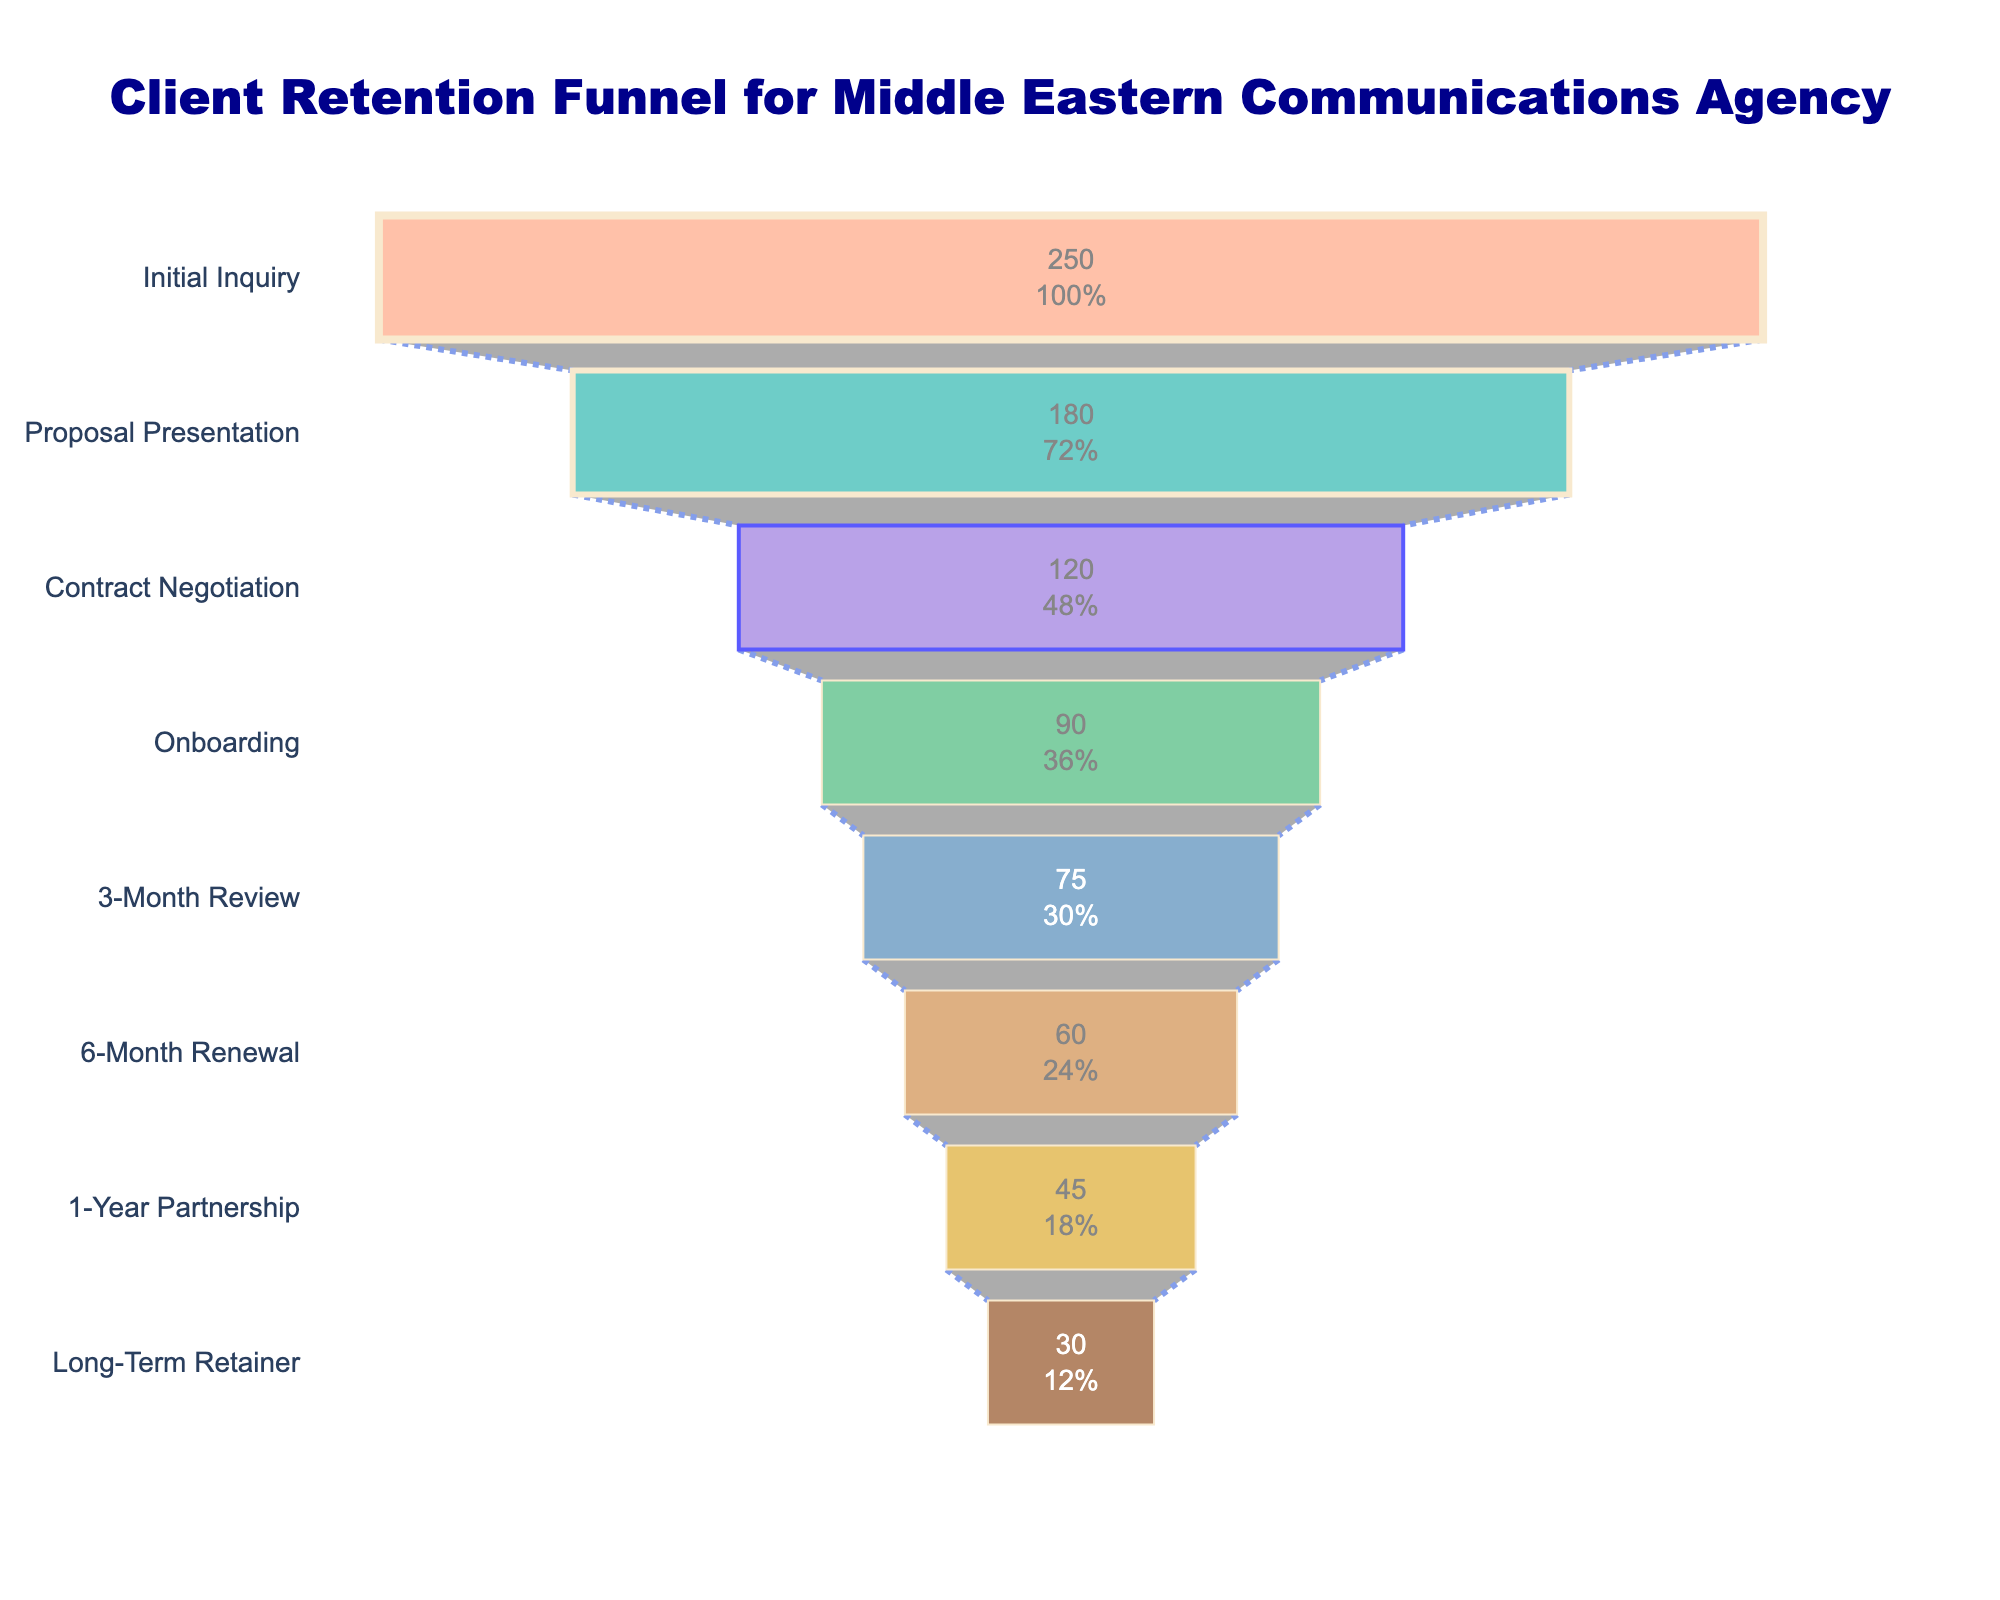what is the title of the funnel chart? The title is usually located at the top of the chart. It is framed to give an overview of what the chart represents. Here, the title clearly states the purpose of the chart.
Answer: Client Retention Funnel for Middle Eastern Communications Agency Which stage has the highest number of clients? The highest value in the funnel chart will be at the widest part, which represents the initial stage in a funnel.
Answer: Initial Inquiry What are the colors used in the funnel chart? Different colors are used to differentiate the stages in the funnel. The provided data in the code shows which colors are used.
Answer: Light Salmon, Light Sea Green, Medium Purple, Medium Sea Green, Steel Blue, Peru, Goldenrod, Saddle Brown How many clients progress from Proposal Presentation to Contract Negotiation? The values for each stage are provided. Subtract the number of clients in Contract Negotiation from those in Proposal Presentation to find the number of clients progressing through this stage. Calculation: 180 - 120 = 60
Answer: 60 By how many clients does the number reduce from the 3-Month Review to the 6-Month Renewal stage? This type of question compares two data points. It necessitates subtracting the lower value from the higher value to identify the reduction. Calculation: 75 - 60 = 15
Answer: 15 What percentage of clients from the Initial Inquiry stage reach the Long-Term Retainer stage? This question involves calculating the reduction percentage from one stage to another. To calculate, divide the number of clients in the Long-Term Retainer stage by those in the Initial Inquiry stage and multiply by 100. Calculation: (30/250) * 100 = 12%
Answer: 12% What is the total number of clients who make it to the 1-Year Partnership stage? The number of clients at the 1-Year Partnership stage is directly provided in the data.
Answer: 45 Compare the client retention between the Proposal Presentation and Onboarding stages. How many clients are lost? Subtract the number of clients at the Onboarding stage from those at the Proposal Presentation stage to determine the loss. Calculation: 180 - 90 = 90
Answer: 90 Which stage has the lowest number of clients, and how many clients are there? The stage with the narrowest part of the funnel represents the stage with the lowest number of clients. This value is provided at the last stage.
Answer: Long-Term Retainer, 30 What percentage of clients move from Contract Negotiation to the Onboarding stage? This type of question involves comparing two stages' figures. Divide the number of clients in the Onboarding stage by those in the Contract Negotiation stage and multiply by 100 to find the percentage. Calculation: (90 / 120) * 100 = 75%
Answer: 75% 